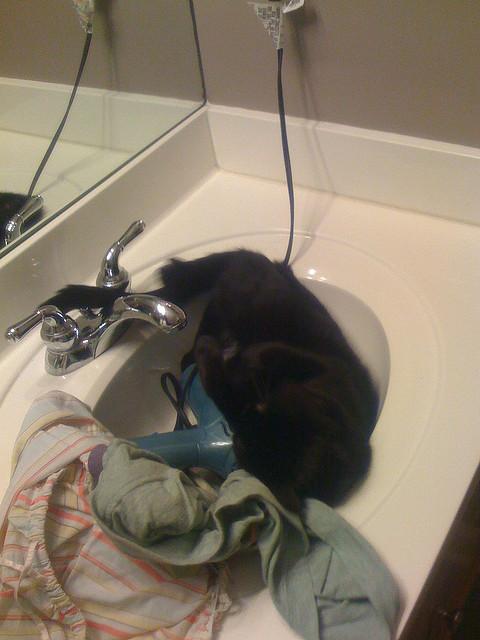How many people in this image are wearing a white jacket?
Give a very brief answer. 0. 